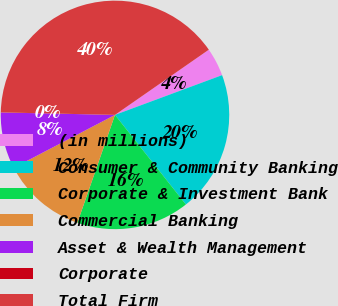Convert chart to OTSL. <chart><loc_0><loc_0><loc_500><loc_500><pie_chart><fcel>(in millions)<fcel>Consumer & Community Banking<fcel>Corporate & Investment Bank<fcel>Commercial Banking<fcel>Asset & Wealth Management<fcel>Corporate<fcel>Total Firm<nl><fcel>4.01%<fcel>20.0%<fcel>16.0%<fcel>12.0%<fcel>8.0%<fcel>0.01%<fcel>39.99%<nl></chart> 